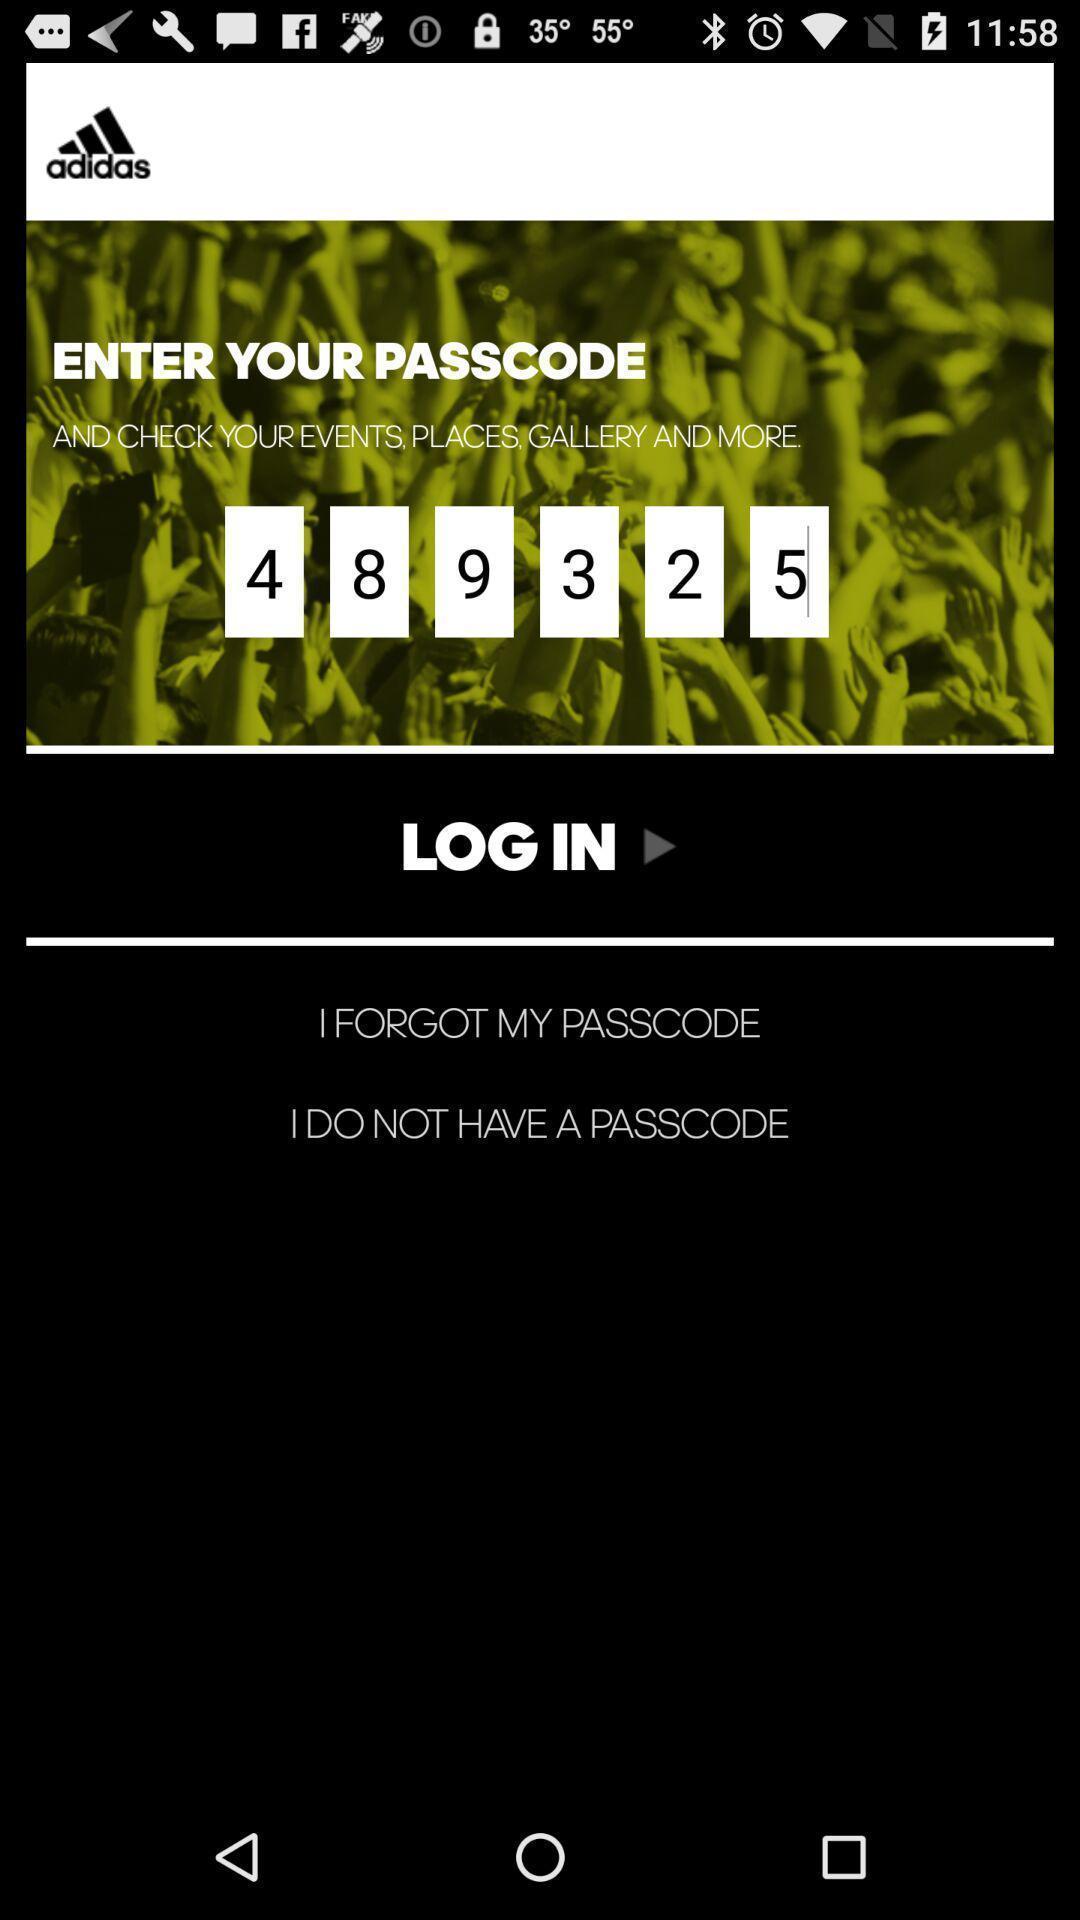Tell me about the visual elements in this screen capture. Page displaying to enter passcode to login. 